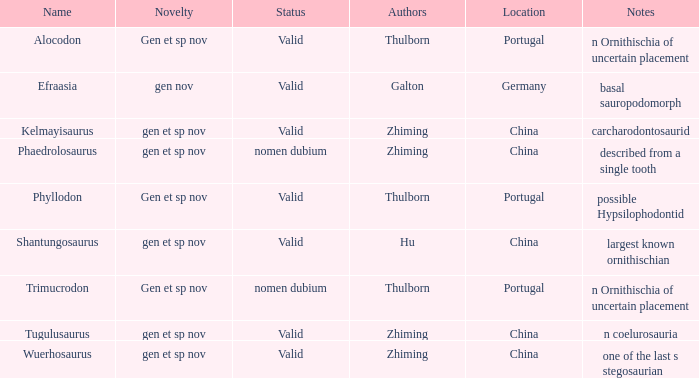What is the designation of the dinosaur, whose descriptions include, "an ornithischia of uncertain placement"? Alocodon, Trimucrodon. 